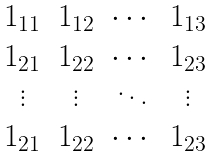Convert formula to latex. <formula><loc_0><loc_0><loc_500><loc_500>\begin{matrix} 1 _ { 1 1 } & 1 _ { 1 2 } & \cdots & 1 _ { 1 3 } \\ 1 _ { 2 1 } & 1 _ { 2 2 } & \cdots & 1 _ { 2 3 } \\ \vdots & \vdots & \ddots & \vdots \\ 1 _ { 2 1 } & 1 _ { 2 2 } & \cdots & 1 _ { 2 3 } \end{matrix}</formula> 